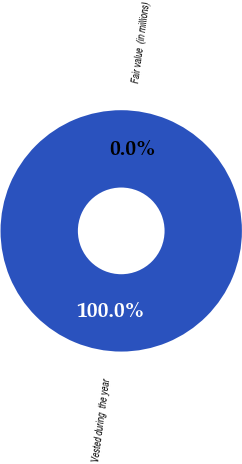Convert chart to OTSL. <chart><loc_0><loc_0><loc_500><loc_500><pie_chart><fcel>Vested during  the year<fcel>Fair value  (in millions)<nl><fcel>100.0%<fcel>0.0%<nl></chart> 